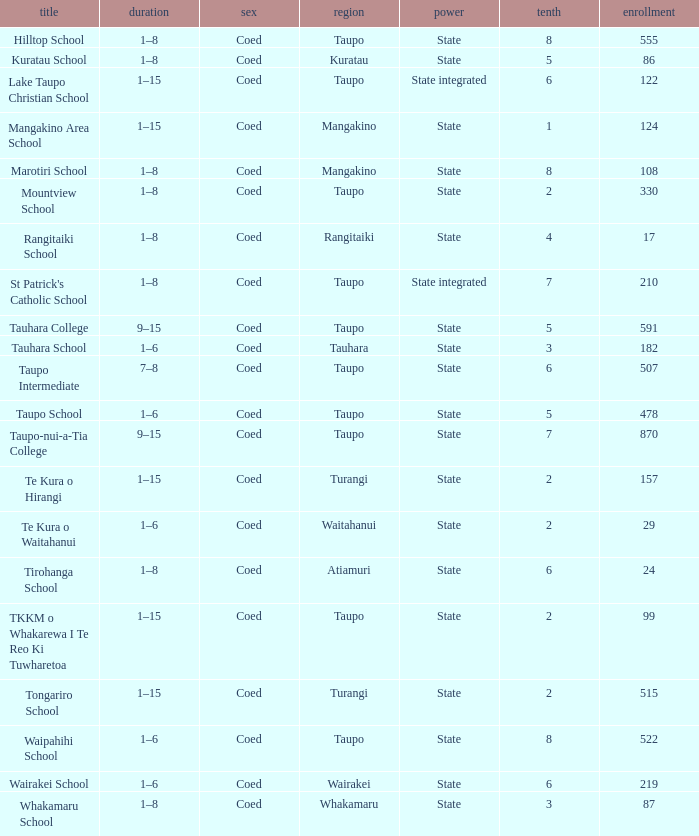What is the Whakamaru school's authority? State. 